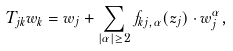<formula> <loc_0><loc_0><loc_500><loc_500>T _ { j k } w _ { k } = w _ { j } + \sum _ { | \alpha | \geq 2 } f _ { k j , \alpha } ( z _ { j } ) \cdot w _ { j } ^ { \alpha } ,</formula> 